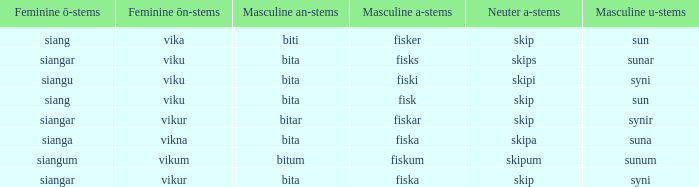What is the masculine u form for the old Swedish word with a neuter a form of skipum? Sunum. 